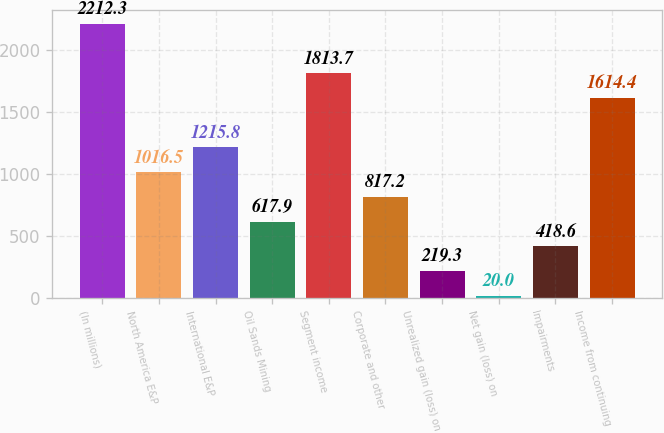Convert chart to OTSL. <chart><loc_0><loc_0><loc_500><loc_500><bar_chart><fcel>(In millions)<fcel>North America E&P<fcel>International E&P<fcel>Oil Sands Mining<fcel>Segment income<fcel>Corporate and other<fcel>Unrealized gain (loss) on<fcel>Net gain (loss) on<fcel>Impairments<fcel>Income from continuing<nl><fcel>2212.3<fcel>1016.5<fcel>1215.8<fcel>617.9<fcel>1813.7<fcel>817.2<fcel>219.3<fcel>20<fcel>418.6<fcel>1614.4<nl></chart> 